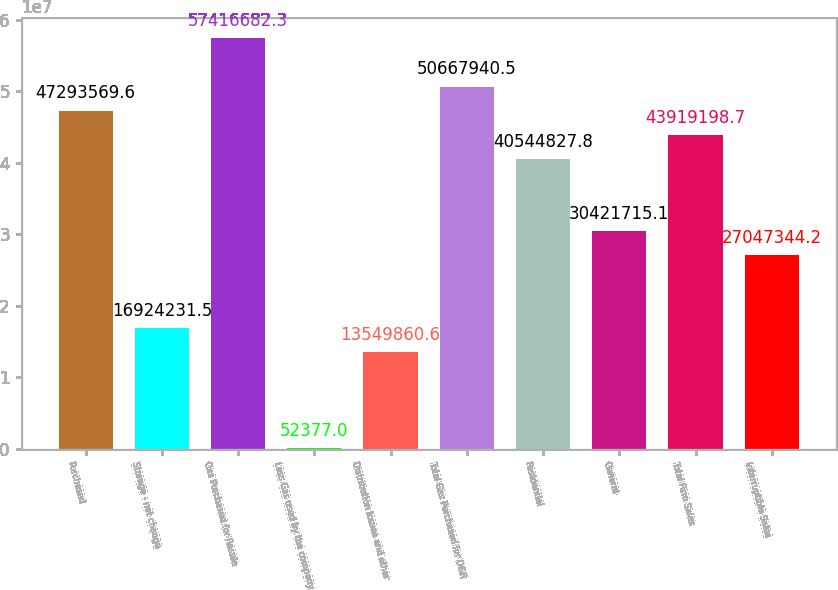Convert chart. <chart><loc_0><loc_0><loc_500><loc_500><bar_chart><fcel>Purchased<fcel>Storage - net change<fcel>Gas Purchased for Resale<fcel>Less Gas used by the company<fcel>Distribution losses and other<fcel>Total Gas Purchased for O&R<fcel>Residential<fcel>General<fcel>Total Firm Sales<fcel>Interruptible Sales<nl><fcel>4.72936e+07<fcel>1.69242e+07<fcel>5.74167e+07<fcel>52377<fcel>1.35499e+07<fcel>5.06679e+07<fcel>4.05448e+07<fcel>3.04217e+07<fcel>4.39192e+07<fcel>2.70473e+07<nl></chart> 